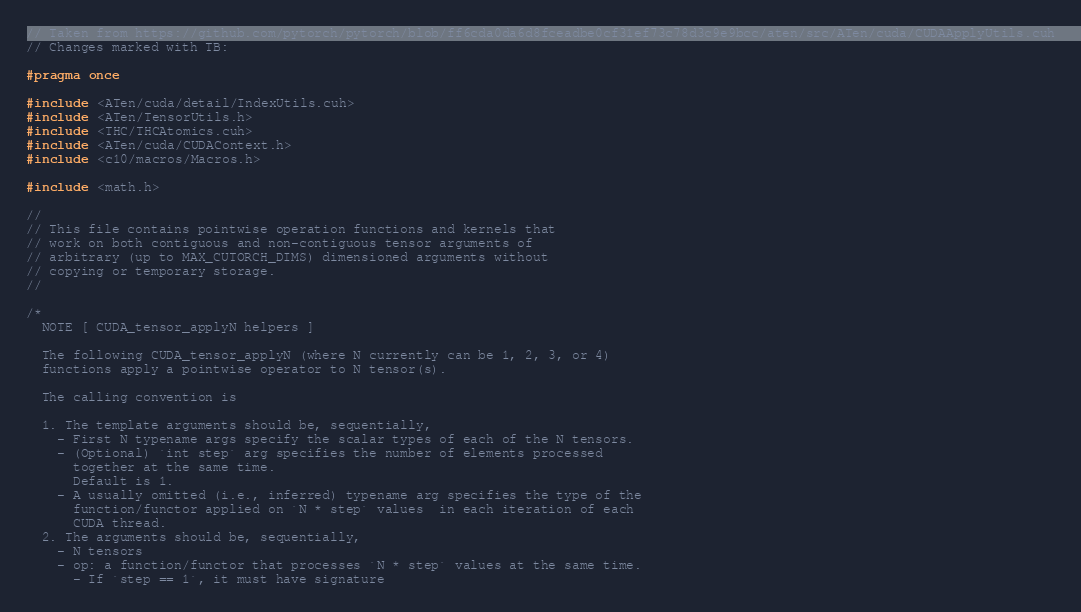Convert code to text. <code><loc_0><loc_0><loc_500><loc_500><_Cuda_>
// Taken from https://github.com/pytorch/pytorch/blob/ff6cda0da6d8fceadbe0cf31ef73c78d3c9e9bcc/aten/src/ATen/cuda/CUDAApplyUtils.cuh
// Changes marked with TB:

#pragma once

#include <ATen/cuda/detail/IndexUtils.cuh>
#include <ATen/TensorUtils.h>
#include <THC/THCAtomics.cuh>
#include <ATen/cuda/CUDAContext.h>
#include <c10/macros/Macros.h>

#include <math.h>

//
// This file contains pointwise operation functions and kernels that
// work on both contiguous and non-contiguous tensor arguments of
// arbitrary (up to MAX_CUTORCH_DIMS) dimensioned arguments without
// copying or temporary storage.
//

/*
  NOTE [ CUDA_tensor_applyN helpers ]

  The following CUDA_tensor_applyN (where N currently can be 1, 2, 3, or 4)
  functions apply a pointwise operator to N tensor(s).

  The calling convention is

  1. The template arguments should be, sequentially,
    - First N typename args specify the scalar types of each of the N tensors.
    - (Optional) `int step` arg specifies the number of elements processed
      together at the same time.
      Default is 1.
    - A usually omitted (i.e., inferred) typename arg specifies the type of the
      function/functor applied on `N * step` values  in each iteration of each
      CUDA thread.
  2. The arguments should be, sequentially,
    - N tensors
    - op: a function/functor that processes `N * step` values at the same time.
      - If `step == 1`, it must have signature</code> 